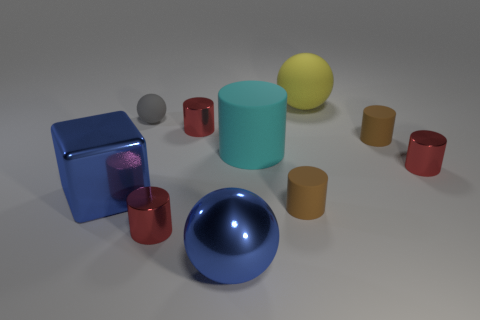Subtract all cyan blocks. How many red cylinders are left? 3 Subtract all big cylinders. How many cylinders are left? 5 Subtract all brown cylinders. How many cylinders are left? 4 Subtract all blue cylinders. Subtract all gray blocks. How many cylinders are left? 6 Subtract all spheres. How many objects are left? 7 Subtract all matte spheres. Subtract all large blue metal cubes. How many objects are left? 7 Add 3 large blue blocks. How many large blue blocks are left? 4 Add 4 brown objects. How many brown objects exist? 6 Subtract 0 red spheres. How many objects are left? 10 